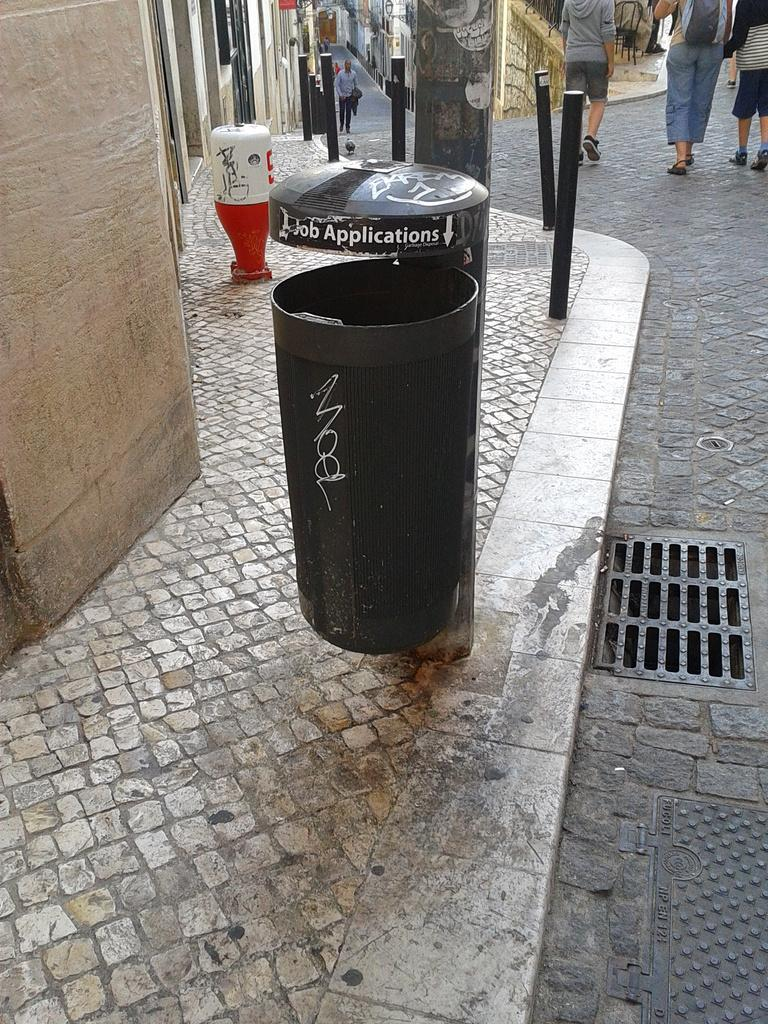<image>
Summarize the visual content of the image. A BLACK SIDEWALK TRASHCAN WITH A JOB APPLICATION BUMMER STICKER 